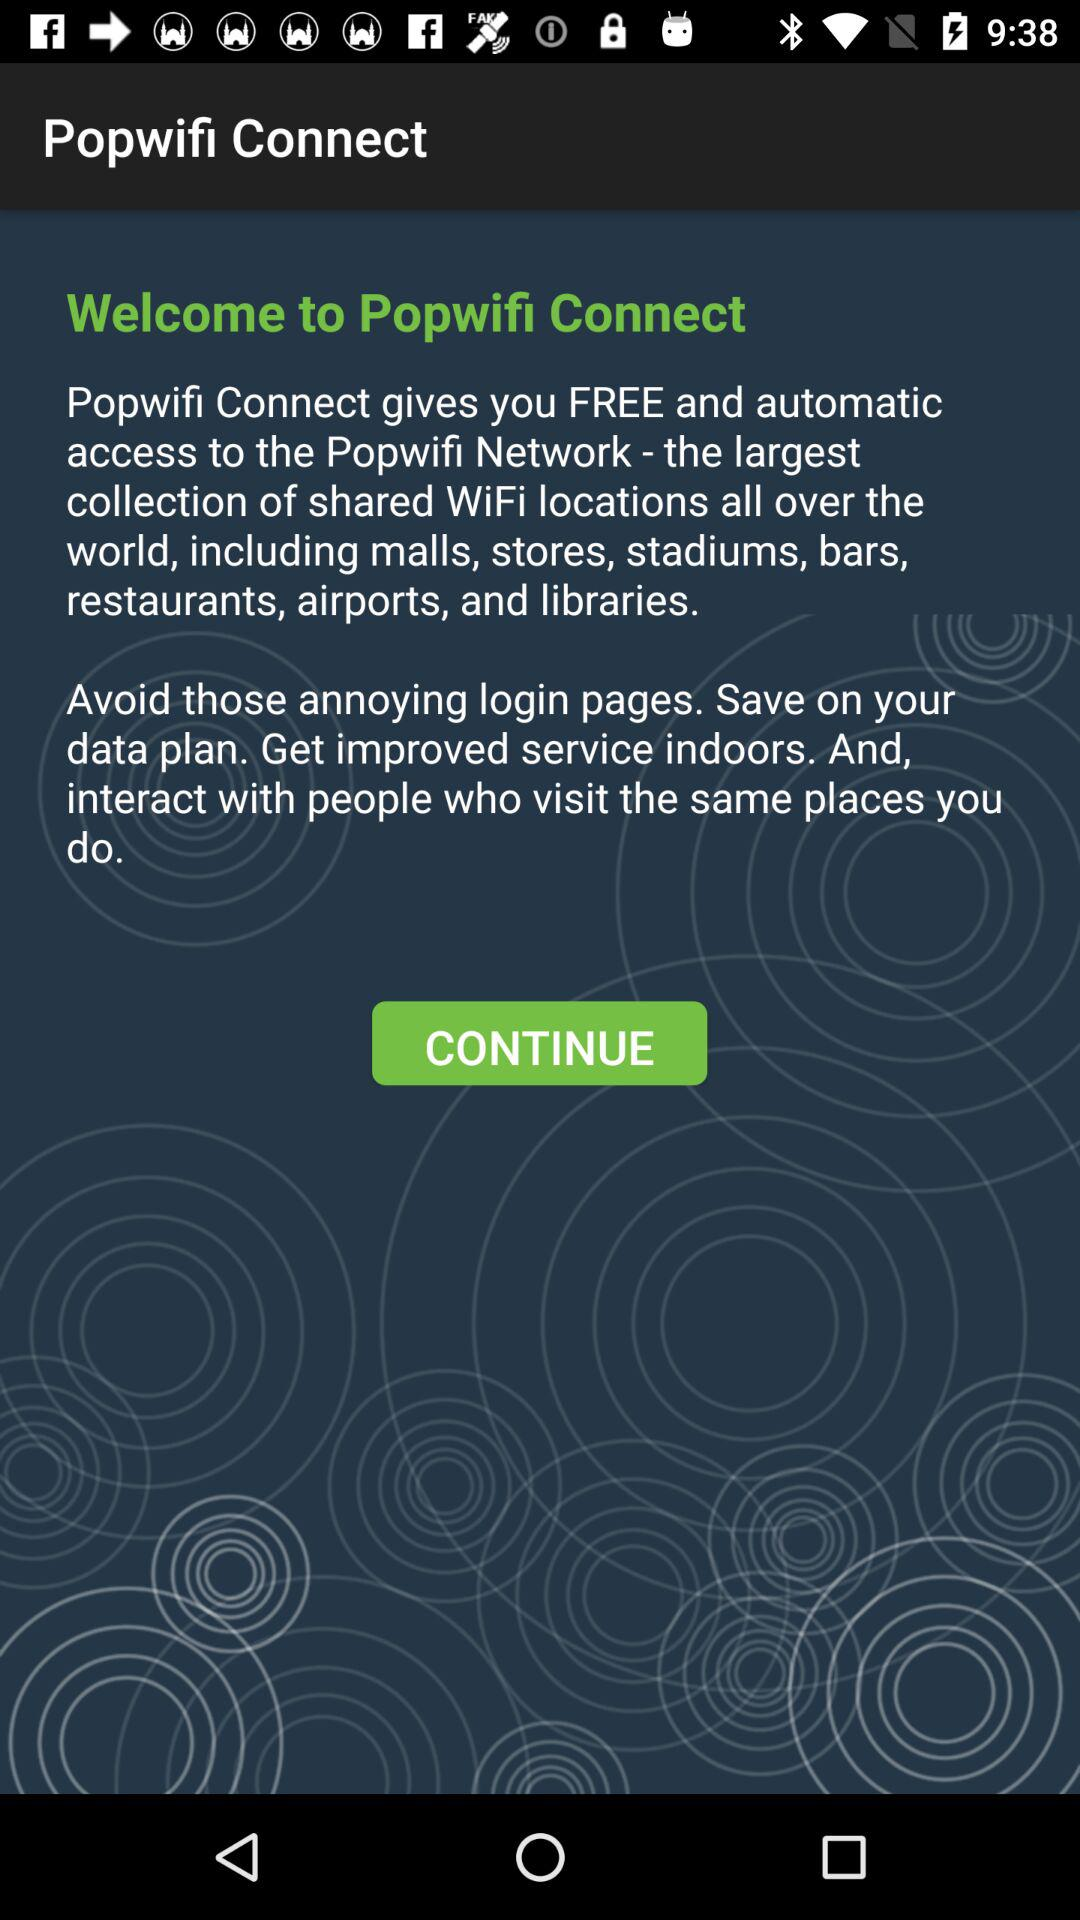What is the application name? The application name is "Popwifi Connect". 